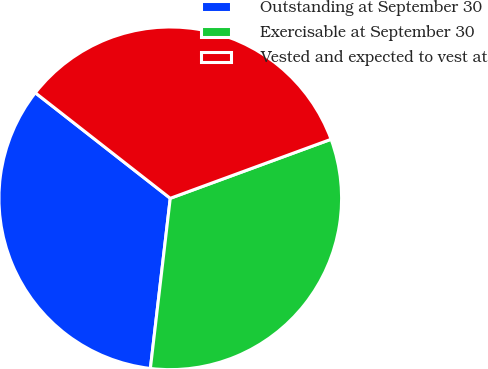Convert chart to OTSL. <chart><loc_0><loc_0><loc_500><loc_500><pie_chart><fcel>Outstanding at September 30<fcel>Exercisable at September 30<fcel>Vested and expected to vest at<nl><fcel>33.71%<fcel>32.45%<fcel>33.84%<nl></chart> 